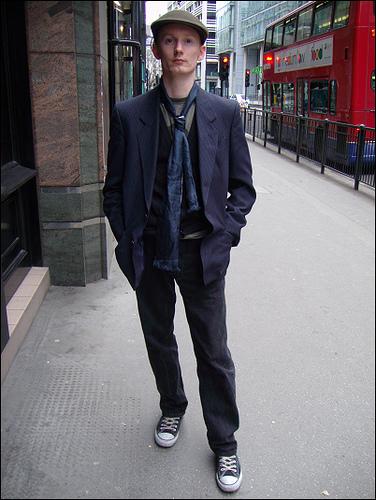What tie is seen?
Be succinct. Blue. Is he wearing a hat?
Give a very brief answer. Yes. Is he wearing a scarf?
Short answer required. Yes. What is the floor made of?
Keep it brief. Concrete. Is the man dressed in a suit?
Give a very brief answer. Yes. What helps this man see us better?
Concise answer only. Glasses. What color is the man's suit?
Concise answer only. Black. What color is the man's scarf?
Concise answer only. Blue. How many women are in this photo?
Give a very brief answer. 0. Is the man cold?
Write a very short answer. No. What form of transit is shown?
Be succinct. Bus. Does the man have a beard?
Be succinct. No. Do his shoes match his jacket?
Quick response, please. Yes. Is the man wearing a striped shirt?
Give a very brief answer. No. How many hands does he have in his pockets?
Short answer required. 2. What type of suit is this?
Quick response, please. Casual. How many steps are there?
Keep it brief. 1. What is the red thing behind him?
Write a very short answer. Bus. How many women are posing?
Answer briefly. 0. Is this an office?
Quick response, please. No. 